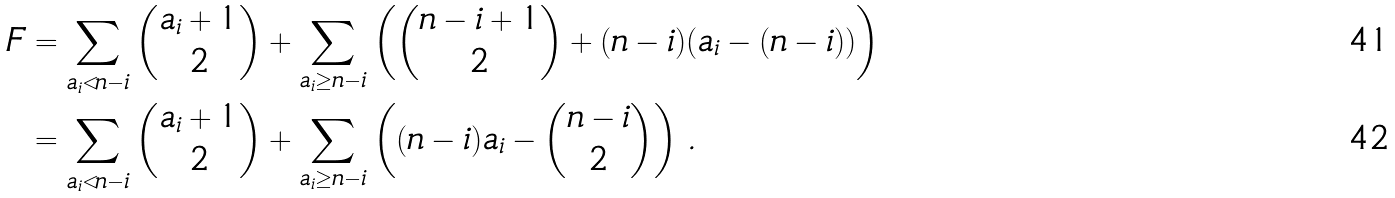Convert formula to latex. <formula><loc_0><loc_0><loc_500><loc_500>F & = \sum _ { a _ { i } < n - i } \binom { a _ { i } + 1 } { 2 } + \sum _ { a _ { i } \geq n - i } \left ( \binom { n - i + 1 } { 2 } + ( n - i ) ( a _ { i } - ( n - i ) ) \right ) \\ & = \sum _ { a _ { i } < n - i } \binom { a _ { i } + 1 } { 2 } + \sum _ { a _ { i } \geq n - i } \left ( ( n - i ) a _ { i } - \binom { n - i } { 2 } \right ) \, .</formula> 